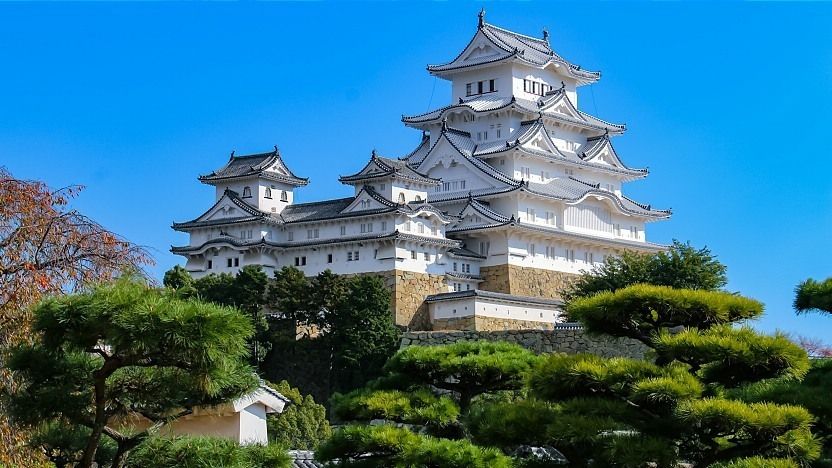If you could time travel, what events related to this castle might we witness in the 16th century? Traveling back to the 16th century at Himeji Castle would place us within a period of significant historical events. We might witness the strategic military maneuvers and construction enhancements made by Toyotomi Hideyoshi, who in 1581 commissioned a large-scale renovation of the castle. This era was marked by feudal conflicts and alliance formations, as Japan moved towards unification under the shogunate. We might also witness the daily life in the castle, the administrative proceedings, and preparations for defense against potential sieges, reflecting the castle’s role as both a military stronghold and a center of governance. Imagine a mysterious legend or folklore that could be associated with Himeji Castle. Legend has it that Himeji Castle is guarded by the spirit of a noble sharegpt4v/samurai who once made the ultimate sacrifice to protect its walls. As the story goes, during a fierce siege, the sharegpt4v/samurai bravely led a small contingent of warriors to a secret underground passage, thwarting their enemies from within. His sacrifice turned the tide of battle, saving the castle from devastation. Locals believe that during the quietest nights, especially under a full moon, the ghostly apparition of the sharegpt4v/samurai can be seen patrolling the castle grounds, forever bound to his oath of protection. This ethereal guardian is said to bring good fortune to those who catch a glimpse of him, reinforcing the castle's legendary status. 